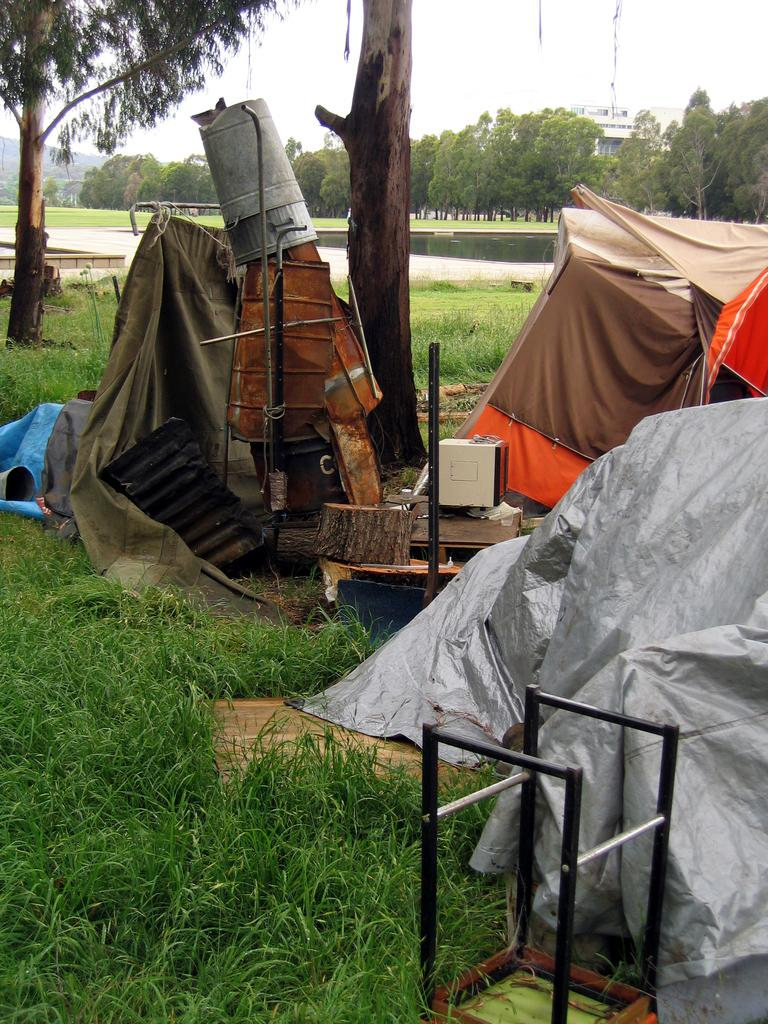What type of natural environment is visible in the image? There is grass in the image, which suggests a natural environment. What type of temporary shelters can be seen in the image? There are tents in the image. What type of vegetation is present in the image? There are trees in the image. What type of permanent structures can be seen in the image? There are buildings in the image. What type of geographical feature is present in the image? There are hills in the image. What is visible in the sky in the image? The sky is visible in the image. What historical event is being commemorated by the person in the image? There is no person present in the image, and therefore no historical event can be observed. What type of pocket is visible on the person in the image? There is no person present in the image, and therefore no pocket can be observed. 